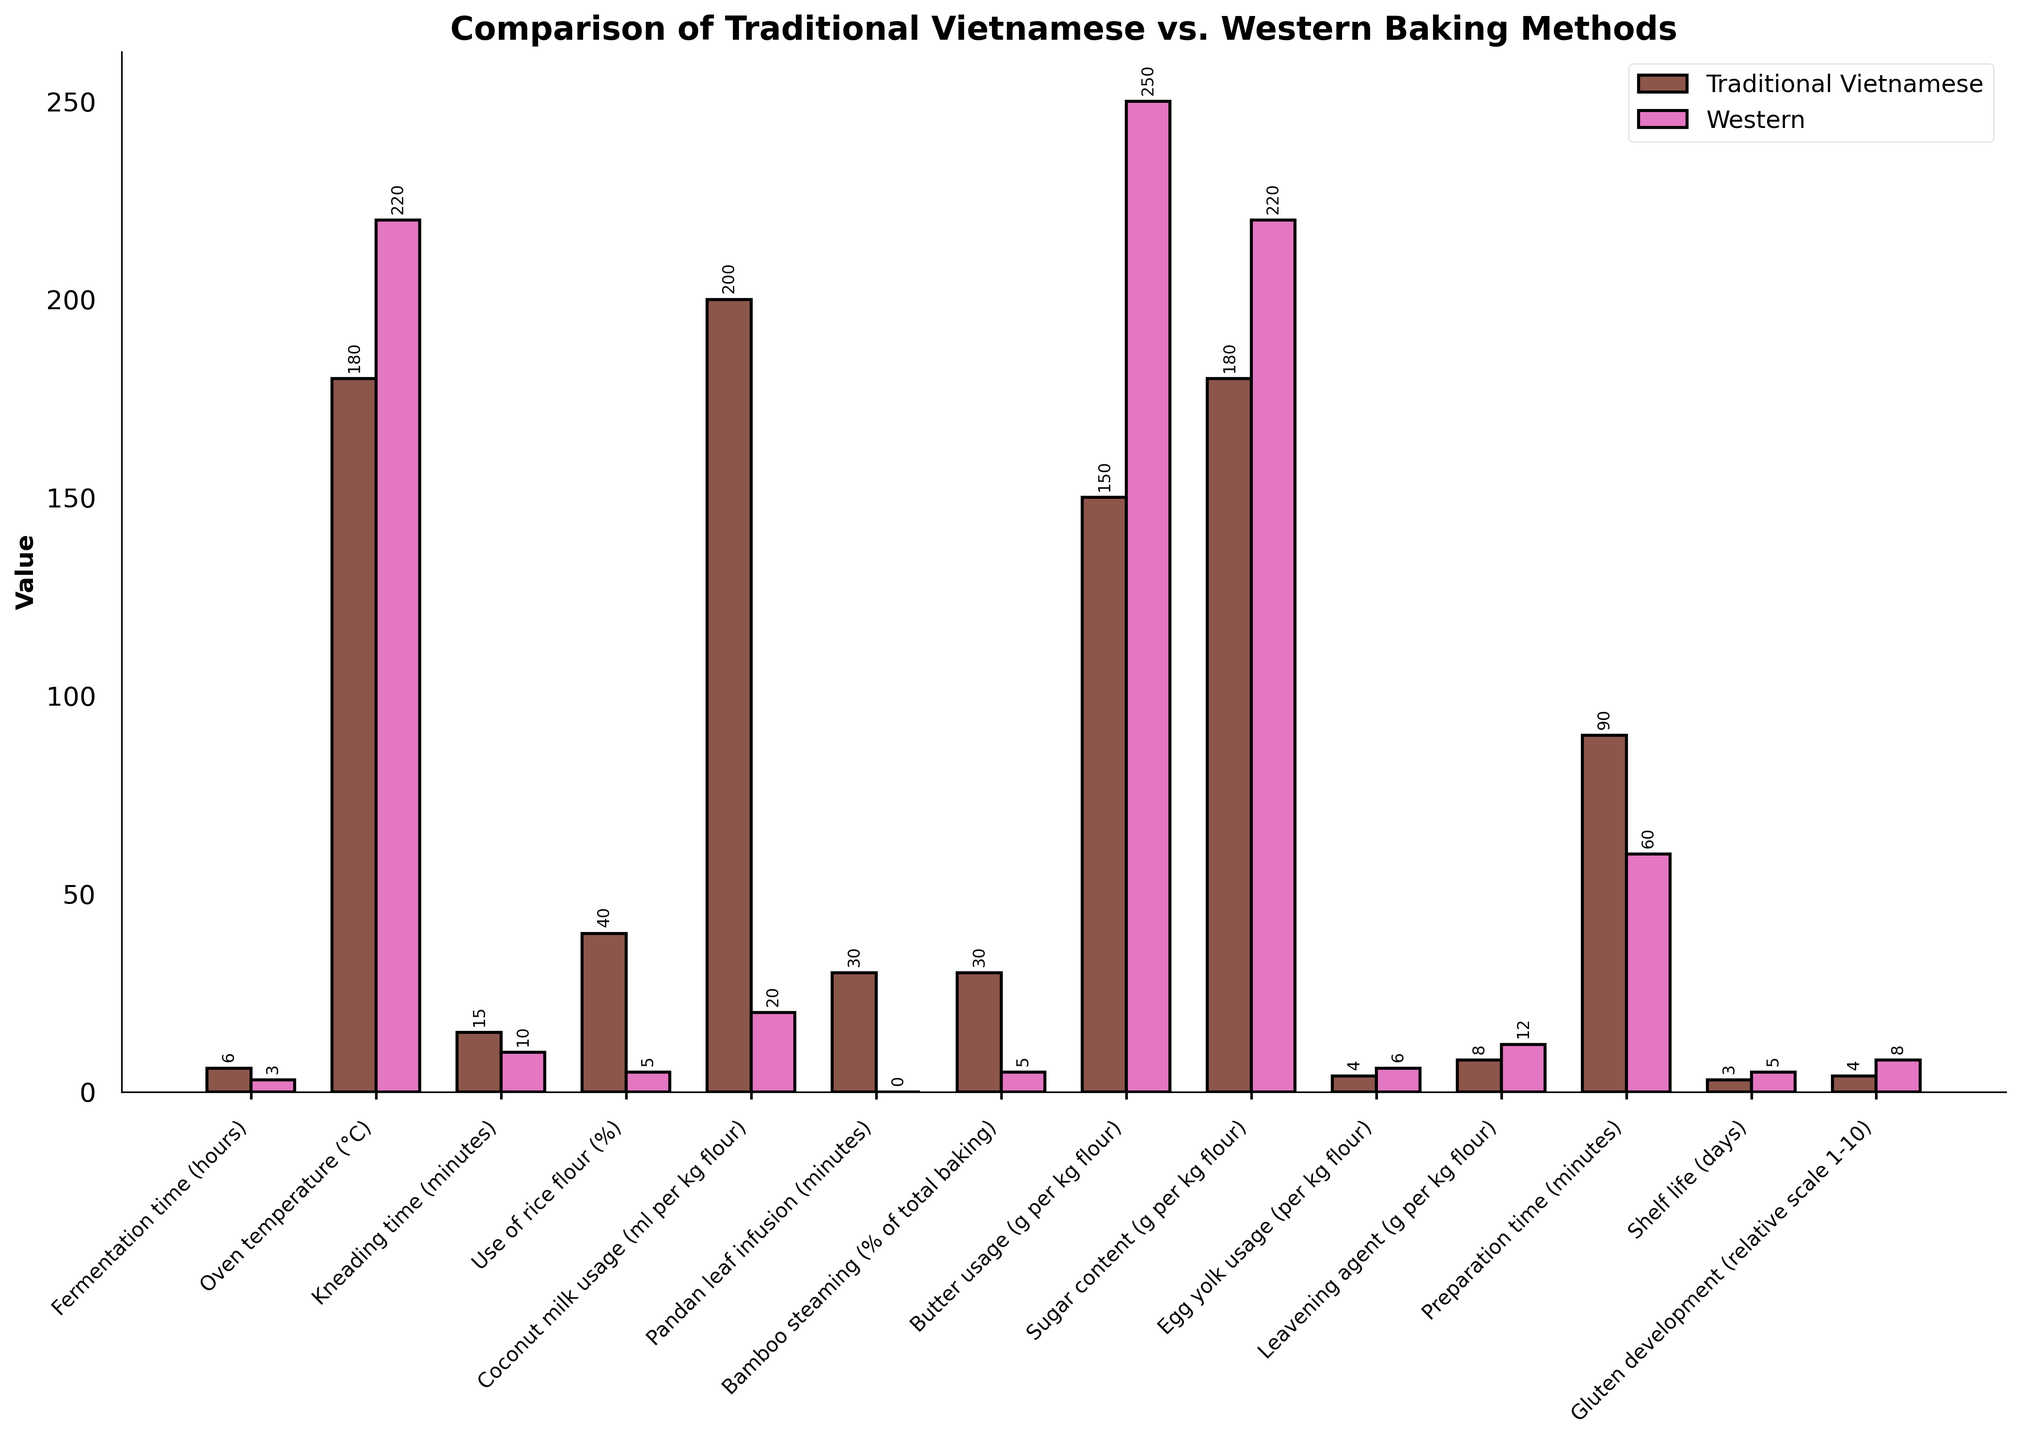How much longer is the fermentation time for Traditional Vietnamese methods compared to Western methods? Traditional Vietnamese fermentation time is 6 hours, and Western is 3 hours. The difference is 6 - 3 = 3 hours.
Answer: 3 hours Which method involves a higher oven temperature and by how much? The oven temperature for Traditional Vietnamese methods is 180°C, while for Western methods it is 220°C. The difference is 220 - 180 = 40°C.
Answer: 40°C How much more rice flour is used in Traditional Vietnamese methods compared to Western methods? Traditional Vietnamese methods use 40% rice flour, whereas Western methods use 5%. The difference is 40 - 5 = 35%.
Answer: 35% What is the total preparation time for both baking methods combined? Traditional Vietnamese preparation time is 90 minutes, and Western is 60 minutes. The total is 90 + 60 = 150 minutes.
Answer: 150 minutes Which method uses more butter, and by how much? Traditional Vietnamese methods use 150 grams of butter per kg of flour, and Western uses 250 grams. 
The difference is 250 - 150 = 100 grams.
Answer: 100 grams For which ingredient do the two methods have the closest usage amount? Comparing the differences in usage for each ingredient: 
    - Fermentation time: 3 hours 
    - Oven temperature: 40°C 
    - Kneading time: 5 minutes 
    - Rice flour: 35%
    - Coconut milk: 180 ml 
    - Pandan leaf infusion: 30 minutes 
    - Bamboo steaming: 25%
    - Butter: 100 grams 
    - Sugar: 40 grams 
    - Egg yolk: 2 
    - Leavening agent: 4 grams 
    - Preparation time: 30 minutes
    - Shelf life: 2 days
    - Gluten development: 4
The smallest difference is in egg yolk usage.
Answer: Egg yolk usage Which method has a longer shelf life and by how many days? Traditional Vietnamese methods have a shelf life of 3 days, while Western methods have 5 days. The difference is 5 - 3 = 2 days.
Answer: 2 days Which baking method uses a greater proportion of bamboo steaming in their process? Traditional Vietnamese methods use bamboo steaming 30% of the time, while Western methods use it 5%.
Answer: Traditional Vietnamese How does the gluten development in Traditional Vietnamese methods compare to Western methods on a relative scale? Gluten development for Traditional Vietnamese methods is rated at 4, while it is rated at 8 for Western methods.
Answer: 4 and 8 If you sum up the fermentation time and preparation time for each method, which one takes longer overall? Summing fermentation and preparation times, Traditional Vietnamese: 6 hours + 90 minutes = 6.5 hours, and Western: 3 hours + 60 minutes = 4 hours. 6.5 hours is longer than 4 hours.
Answer: Traditional Vietnamese 